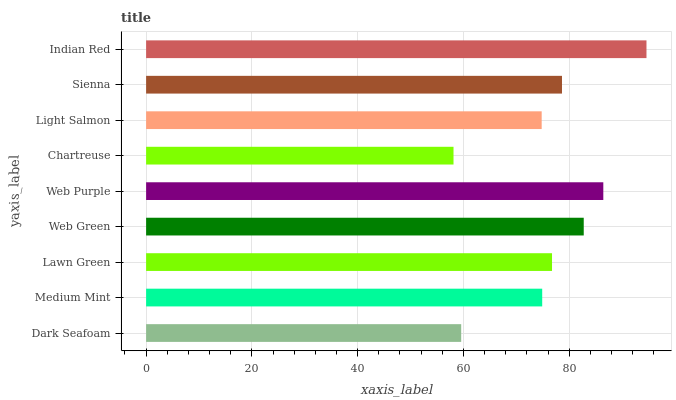Is Chartreuse the minimum?
Answer yes or no. Yes. Is Indian Red the maximum?
Answer yes or no. Yes. Is Medium Mint the minimum?
Answer yes or no. No. Is Medium Mint the maximum?
Answer yes or no. No. Is Medium Mint greater than Dark Seafoam?
Answer yes or no. Yes. Is Dark Seafoam less than Medium Mint?
Answer yes or no. Yes. Is Dark Seafoam greater than Medium Mint?
Answer yes or no. No. Is Medium Mint less than Dark Seafoam?
Answer yes or no. No. Is Lawn Green the high median?
Answer yes or no. Yes. Is Lawn Green the low median?
Answer yes or no. Yes. Is Web Purple the high median?
Answer yes or no. No. Is Chartreuse the low median?
Answer yes or no. No. 